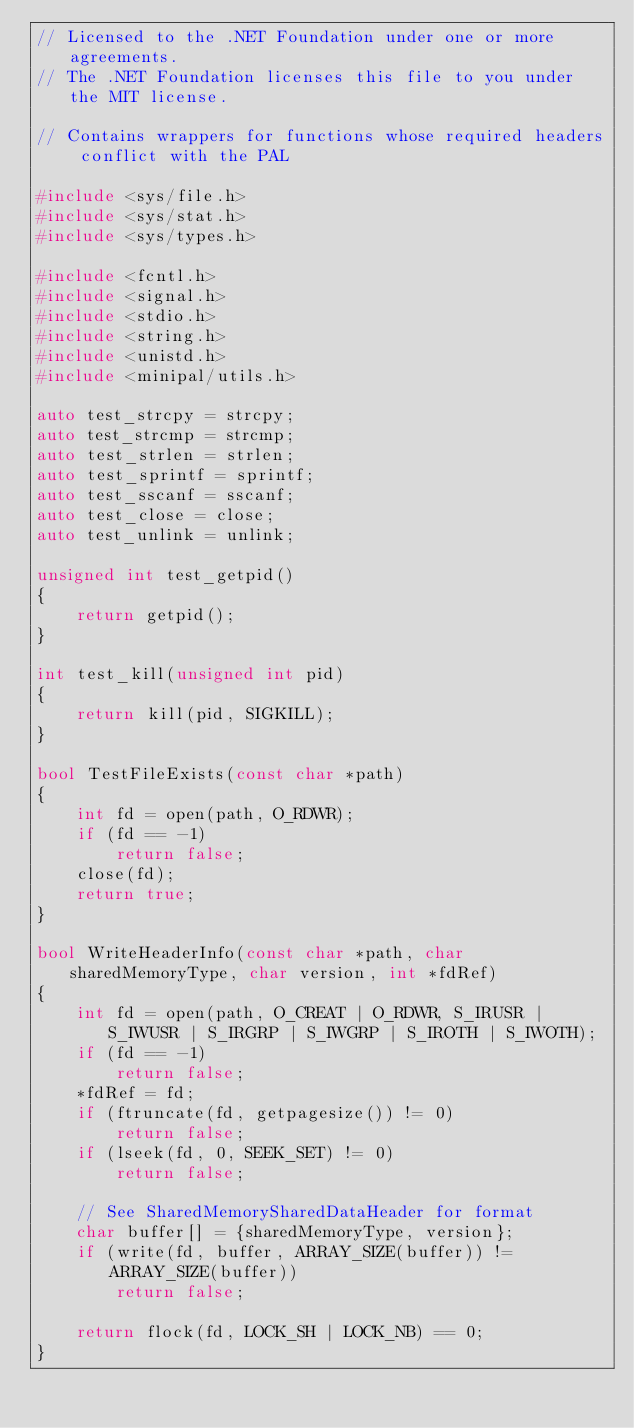<code> <loc_0><loc_0><loc_500><loc_500><_C++_>// Licensed to the .NET Foundation under one or more agreements.
// The .NET Foundation licenses this file to you under the MIT license.

// Contains wrappers for functions whose required headers conflict with the PAL

#include <sys/file.h>
#include <sys/stat.h>
#include <sys/types.h>

#include <fcntl.h>
#include <signal.h>
#include <stdio.h>
#include <string.h>
#include <unistd.h>
#include <minipal/utils.h>

auto test_strcpy = strcpy;
auto test_strcmp = strcmp;
auto test_strlen = strlen;
auto test_sprintf = sprintf;
auto test_sscanf = sscanf;
auto test_close = close;
auto test_unlink = unlink;

unsigned int test_getpid()
{
    return getpid();
}

int test_kill(unsigned int pid)
{
    return kill(pid, SIGKILL);
}

bool TestFileExists(const char *path)
{
    int fd = open(path, O_RDWR);
    if (fd == -1)
        return false;
    close(fd);
    return true;
}

bool WriteHeaderInfo(const char *path, char sharedMemoryType, char version, int *fdRef)
{
    int fd = open(path, O_CREAT | O_RDWR, S_IRUSR | S_IWUSR | S_IRGRP | S_IWGRP | S_IROTH | S_IWOTH);
    if (fd == -1)
        return false;
    *fdRef = fd;
    if (ftruncate(fd, getpagesize()) != 0)
        return false;
    if (lseek(fd, 0, SEEK_SET) != 0)
        return false;

    // See SharedMemorySharedDataHeader for format
    char buffer[] = {sharedMemoryType, version};
    if (write(fd, buffer, ARRAY_SIZE(buffer)) != ARRAY_SIZE(buffer))
        return false;

    return flock(fd, LOCK_SH | LOCK_NB) == 0;
}
</code> 